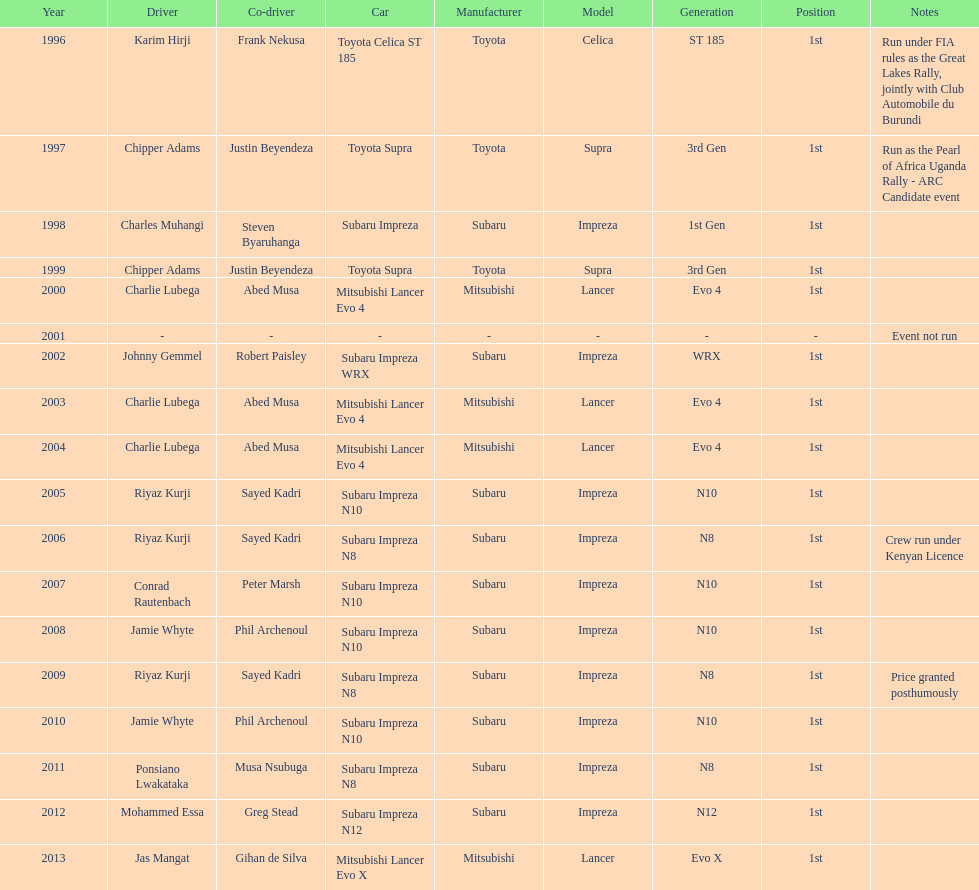Chipper adams and justin beyendeza have how mnay wins? 2. 